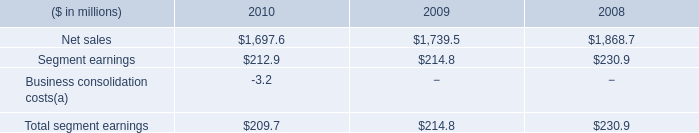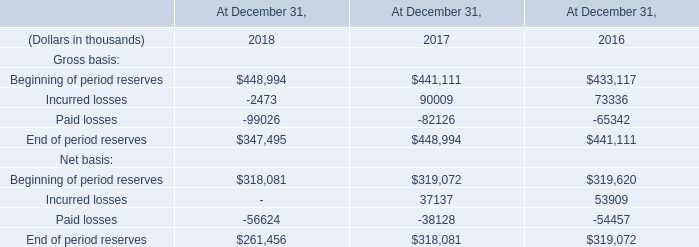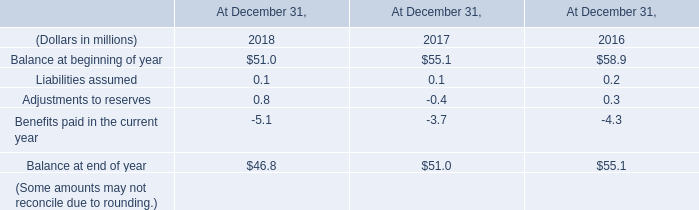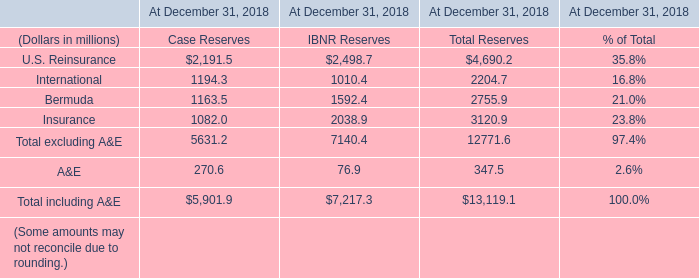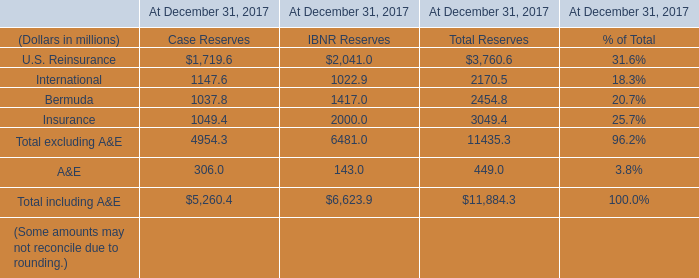What was the average of the Insurance for Case Reserves in the years where U.S. Reinsurance is positive for Case Reserves? (in million) 
Computations: (1049.4 / 1)
Answer: 1049.4. 